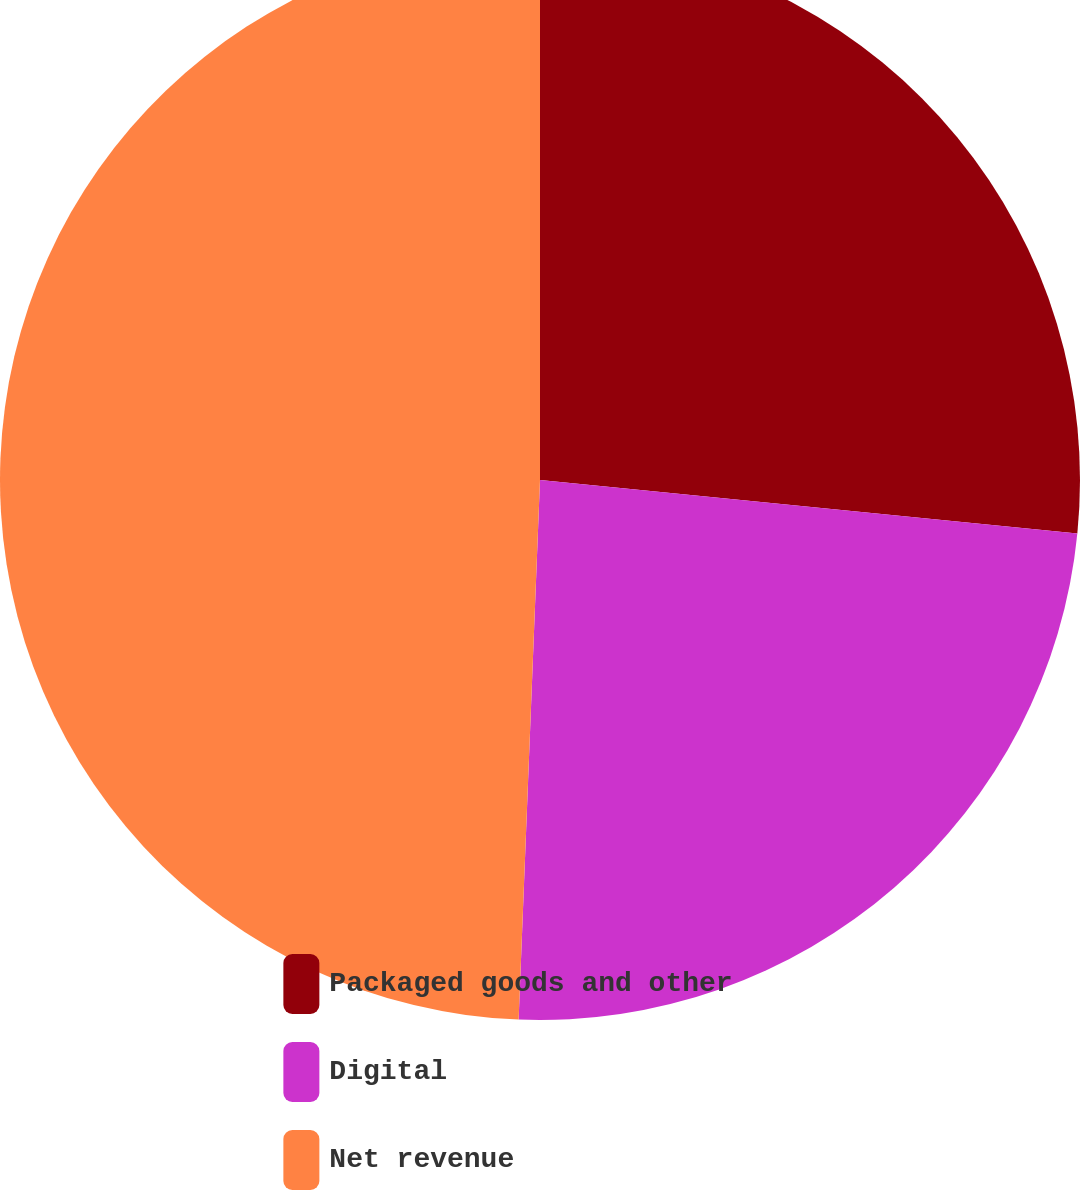Convert chart. <chart><loc_0><loc_0><loc_500><loc_500><pie_chart><fcel>Packaged goods and other<fcel>Digital<fcel>Net revenue<nl><fcel>26.58%<fcel>24.05%<fcel>49.37%<nl></chart> 